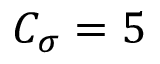<formula> <loc_0><loc_0><loc_500><loc_500>C _ { \sigma } = 5</formula> 